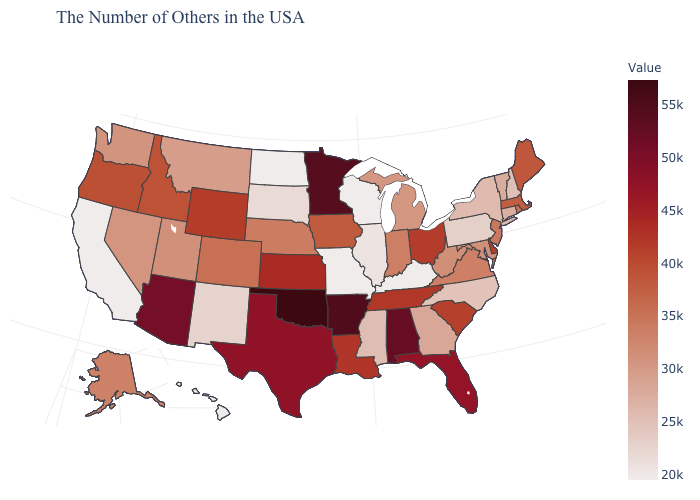Which states have the lowest value in the MidWest?
Concise answer only. Wisconsin, Missouri, North Dakota. Is the legend a continuous bar?
Quick response, please. Yes. Which states have the highest value in the USA?
Give a very brief answer. Oklahoma. Does Mississippi have a higher value than Wyoming?
Be succinct. No. Among the states that border New Mexico , which have the lowest value?
Write a very short answer. Utah. 